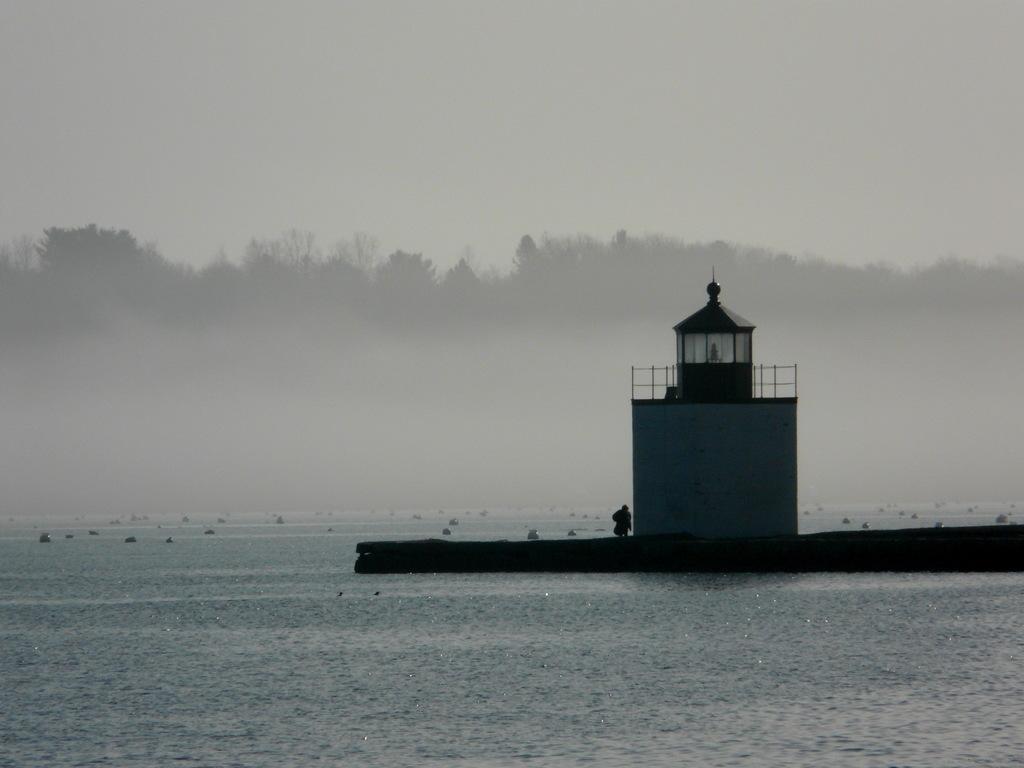Describe this image in one or two sentences. As we can see in the image there is water, a person standing over here, building, trees and sky. The image is little dark. 